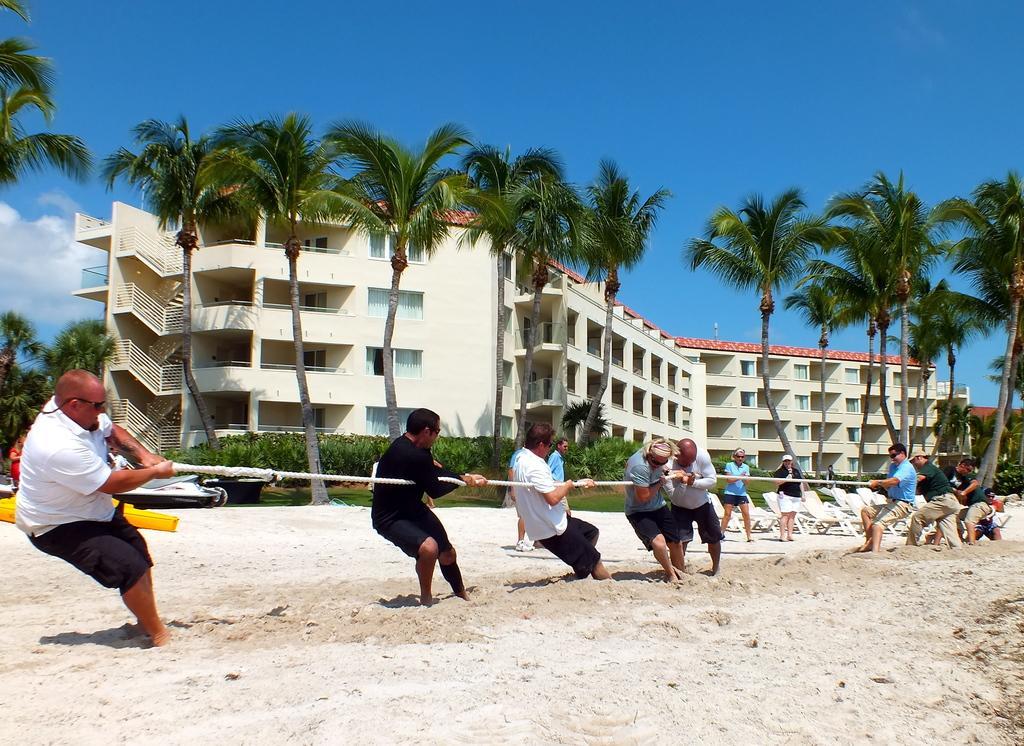Describe this image in one or two sentences. In this picture, there are people playing the rope game. Two groups of people are holding either end of the rope. At the bottom there is sand. Towards the eight, there are two people staring them, In the background there are buildings, trees, plants, sky etc. 